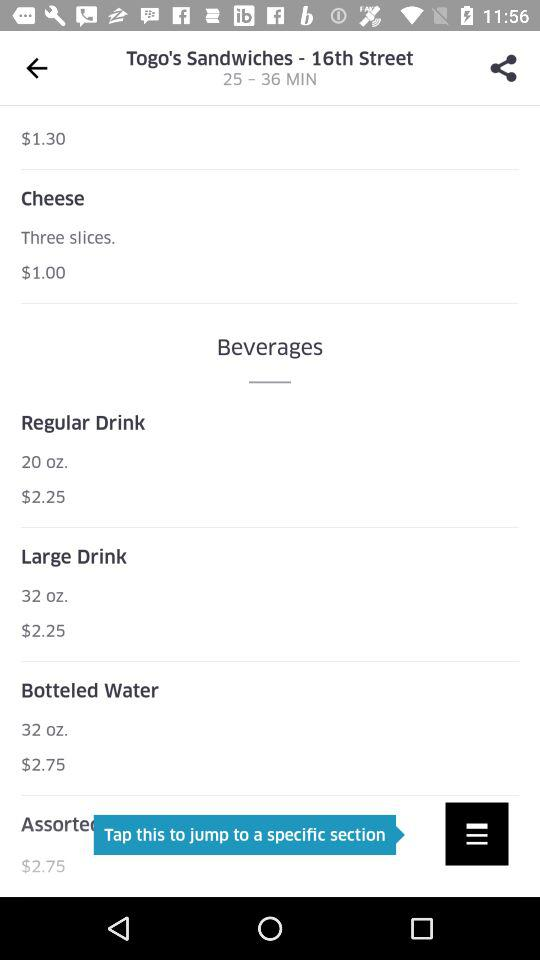What's the minimum delivery time? The minimum delivery time is 25 minutes. 